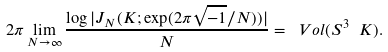<formula> <loc_0><loc_0><loc_500><loc_500>2 \pi \lim _ { N \to \infty } \frac { \log | J _ { N } ( K ; \exp ( 2 \pi \sqrt { - 1 } / N ) ) | } { N } = \ V o l ( S ^ { 3 } \ { K } ) .</formula> 